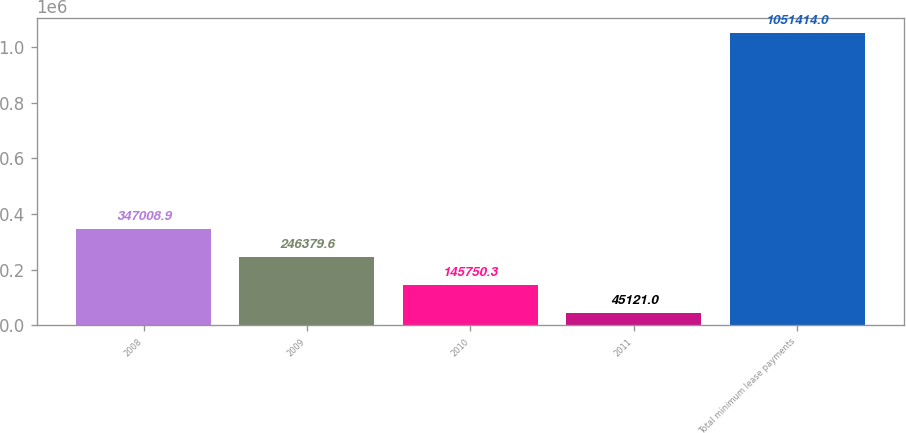Convert chart to OTSL. <chart><loc_0><loc_0><loc_500><loc_500><bar_chart><fcel>2008<fcel>2009<fcel>2010<fcel>2011<fcel>Total minimum lease payments<nl><fcel>347009<fcel>246380<fcel>145750<fcel>45121<fcel>1.05141e+06<nl></chart> 